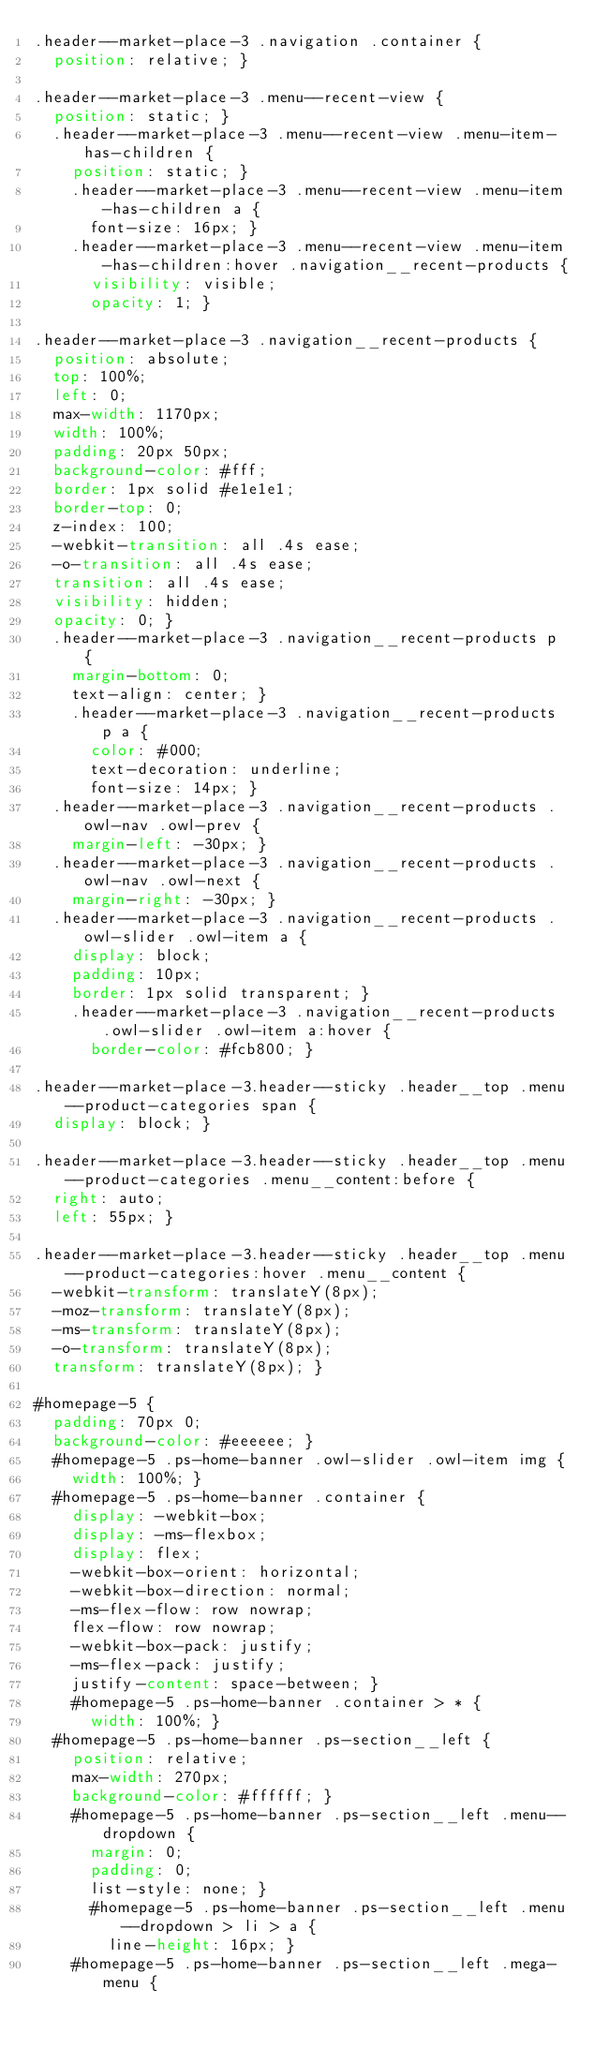Convert code to text. <code><loc_0><loc_0><loc_500><loc_500><_CSS_>.header--market-place-3 .navigation .container {
  position: relative; }

.header--market-place-3 .menu--recent-view {
  position: static; }
  .header--market-place-3 .menu--recent-view .menu-item-has-children {
    position: static; }
    .header--market-place-3 .menu--recent-view .menu-item-has-children a {
      font-size: 16px; }
    .header--market-place-3 .menu--recent-view .menu-item-has-children:hover .navigation__recent-products {
      visibility: visible;
      opacity: 1; }

.header--market-place-3 .navigation__recent-products {
  position: absolute;
  top: 100%;
  left: 0;
  max-width: 1170px;
  width: 100%;
  padding: 20px 50px;
  background-color: #fff;
  border: 1px solid #e1e1e1;
  border-top: 0;
  z-index: 100;
  -webkit-transition: all .4s ease;
  -o-transition: all .4s ease;
  transition: all .4s ease;
  visibility: hidden;
  opacity: 0; }
  .header--market-place-3 .navigation__recent-products p {
    margin-bottom: 0;
    text-align: center; }
    .header--market-place-3 .navigation__recent-products p a {
      color: #000;
      text-decoration: underline;
      font-size: 14px; }
  .header--market-place-3 .navigation__recent-products .owl-nav .owl-prev {
    margin-left: -30px; }
  .header--market-place-3 .navigation__recent-products .owl-nav .owl-next {
    margin-right: -30px; }
  .header--market-place-3 .navigation__recent-products .owl-slider .owl-item a {
    display: block;
    padding: 10px;
    border: 1px solid transparent; }
    .header--market-place-3 .navigation__recent-products .owl-slider .owl-item a:hover {
      border-color: #fcb800; }

.header--market-place-3.header--sticky .header__top .menu--product-categories span {
  display: block; }

.header--market-place-3.header--sticky .header__top .menu--product-categories .menu__content:before {
  right: auto;
  left: 55px; }

.header--market-place-3.header--sticky .header__top .menu--product-categories:hover .menu__content {
  -webkit-transform: translateY(8px);
  -moz-transform: translateY(8px);
  -ms-transform: translateY(8px);
  -o-transform: translateY(8px);
  transform: translateY(8px); }

#homepage-5 {
  padding: 70px 0;
  background-color: #eeeeee; }
  #homepage-5 .ps-home-banner .owl-slider .owl-item img {
    width: 100%; }
  #homepage-5 .ps-home-banner .container {
    display: -webkit-box;
    display: -ms-flexbox;
    display: flex;
    -webkit-box-orient: horizontal;
    -webkit-box-direction: normal;
    -ms-flex-flow: row nowrap;
    flex-flow: row nowrap;
    -webkit-box-pack: justify;
    -ms-flex-pack: justify;
    justify-content: space-between; }
    #homepage-5 .ps-home-banner .container > * {
      width: 100%; }
  #homepage-5 .ps-home-banner .ps-section__left {
    position: relative;
    max-width: 270px;
    background-color: #ffffff; }
    #homepage-5 .ps-home-banner .ps-section__left .menu--dropdown {
      margin: 0;
      padding: 0;
      list-style: none; }
      #homepage-5 .ps-home-banner .ps-section__left .menu--dropdown > li > a {
        line-height: 16px; }
    #homepage-5 .ps-home-banner .ps-section__left .mega-menu {</code> 